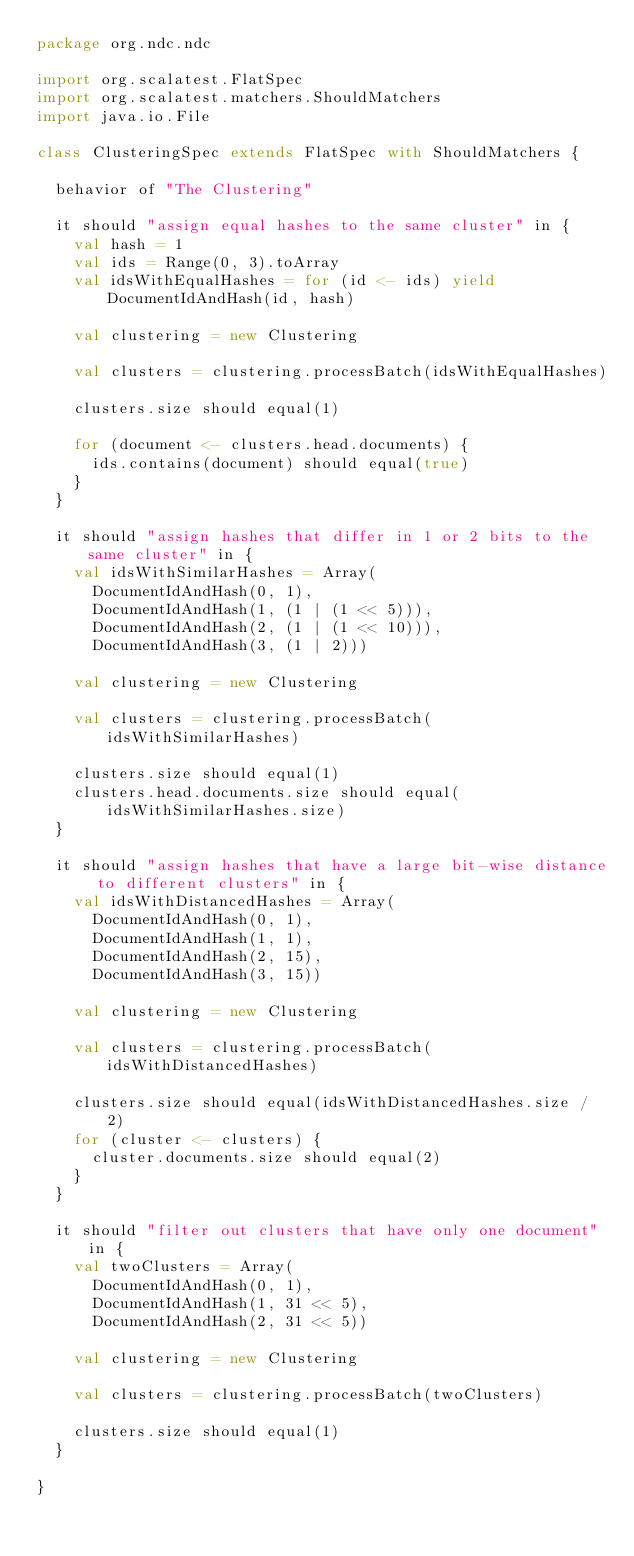Convert code to text. <code><loc_0><loc_0><loc_500><loc_500><_Scala_>package org.ndc.ndc

import org.scalatest.FlatSpec
import org.scalatest.matchers.ShouldMatchers
import java.io.File

class ClusteringSpec extends FlatSpec with ShouldMatchers {

  behavior of "The Clustering"

  it should "assign equal hashes to the same cluster" in {
    val hash = 1
    val ids = Range(0, 3).toArray
    val idsWithEqualHashes = for (id <- ids) yield DocumentIdAndHash(id, hash)

    val clustering = new Clustering

    val clusters = clustering.processBatch(idsWithEqualHashes)

    clusters.size should equal(1)

    for (document <- clusters.head.documents) {
      ids.contains(document) should equal(true)
    }
  }

  it should "assign hashes that differ in 1 or 2 bits to the same cluster" in {
    val idsWithSimilarHashes = Array(
      DocumentIdAndHash(0, 1),
      DocumentIdAndHash(1, (1 | (1 << 5))),
      DocumentIdAndHash(2, (1 | (1 << 10))),
      DocumentIdAndHash(3, (1 | 2)))

    val clustering = new Clustering

    val clusters = clustering.processBatch(idsWithSimilarHashes)

    clusters.size should equal(1)
    clusters.head.documents.size should equal(idsWithSimilarHashes.size)
  }

  it should "assign hashes that have a large bit-wise distance to different clusters" in {
    val idsWithDistancedHashes = Array(
      DocumentIdAndHash(0, 1),
      DocumentIdAndHash(1, 1),
      DocumentIdAndHash(2, 15),
      DocumentIdAndHash(3, 15))

    val clustering = new Clustering

    val clusters = clustering.processBatch(idsWithDistancedHashes)

    clusters.size should equal(idsWithDistancedHashes.size / 2)
    for (cluster <- clusters) {
      cluster.documents.size should equal(2)
    }
  }
  
  it should "filter out clusters that have only one document" in {
    val twoClusters = Array(
      DocumentIdAndHash(0, 1),
      DocumentIdAndHash(1, 31 << 5),
      DocumentIdAndHash(2, 31 << 5))

    val clustering = new Clustering

    val clusters = clustering.processBatch(twoClusters)

    clusters.size should equal(1)    
  }

}</code> 